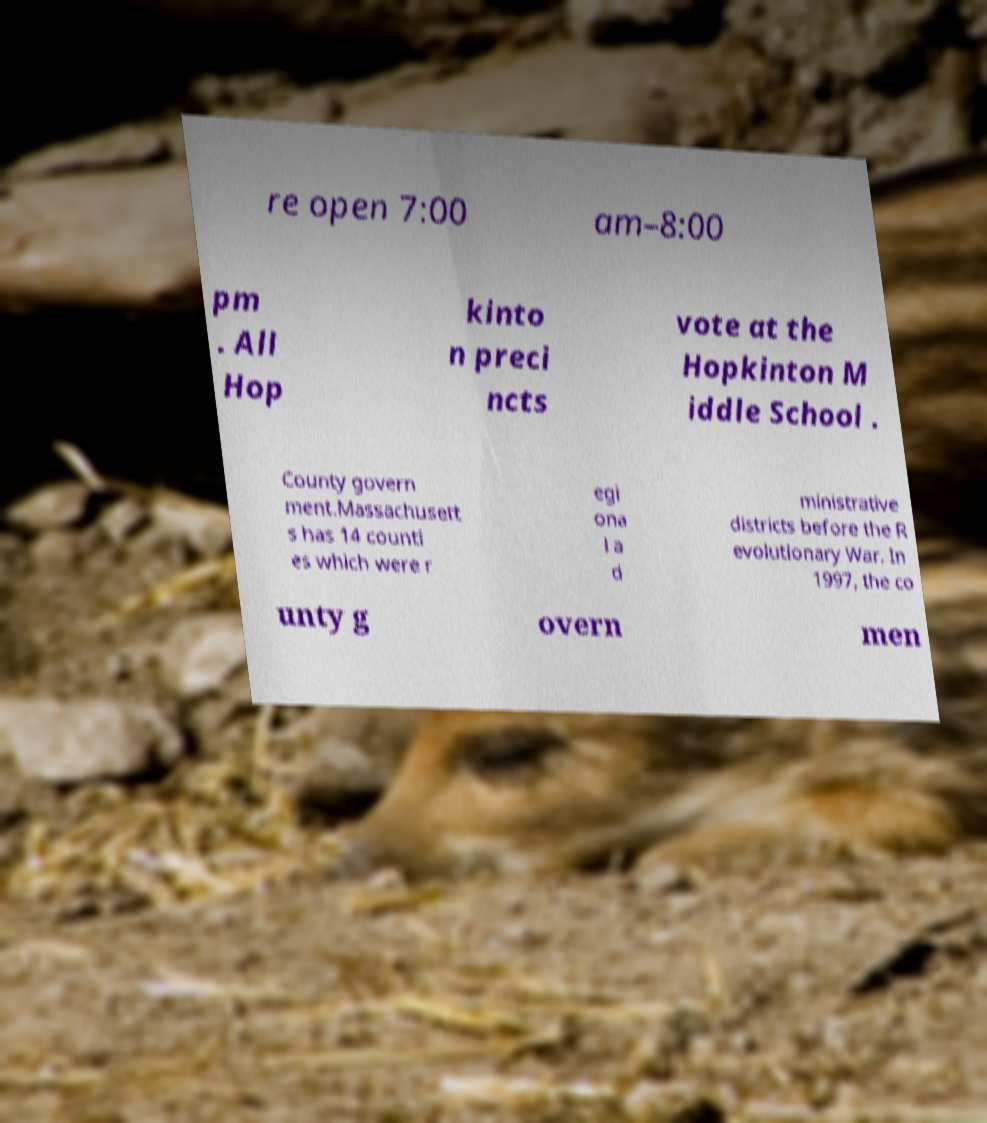Could you extract and type out the text from this image? re open 7:00 am–8:00 pm . All Hop kinto n preci ncts vote at the Hopkinton M iddle School . County govern ment.Massachusett s has 14 counti es which were r egi ona l a d ministrative districts before the R evolutionary War. In 1997, the co unty g overn men 